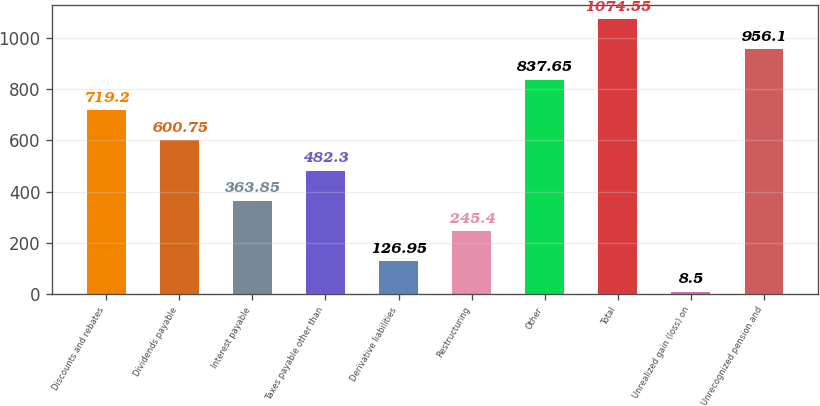Convert chart to OTSL. <chart><loc_0><loc_0><loc_500><loc_500><bar_chart><fcel>Discounts and rebates<fcel>Dividends payable<fcel>Interest payable<fcel>Taxes payable other than<fcel>Derivative liabilities<fcel>Restructuring<fcel>Other<fcel>Total<fcel>Unrealized gain (loss) on<fcel>Unrecognized pension and<nl><fcel>719.2<fcel>600.75<fcel>363.85<fcel>482.3<fcel>126.95<fcel>245.4<fcel>837.65<fcel>1074.55<fcel>8.5<fcel>956.1<nl></chart> 